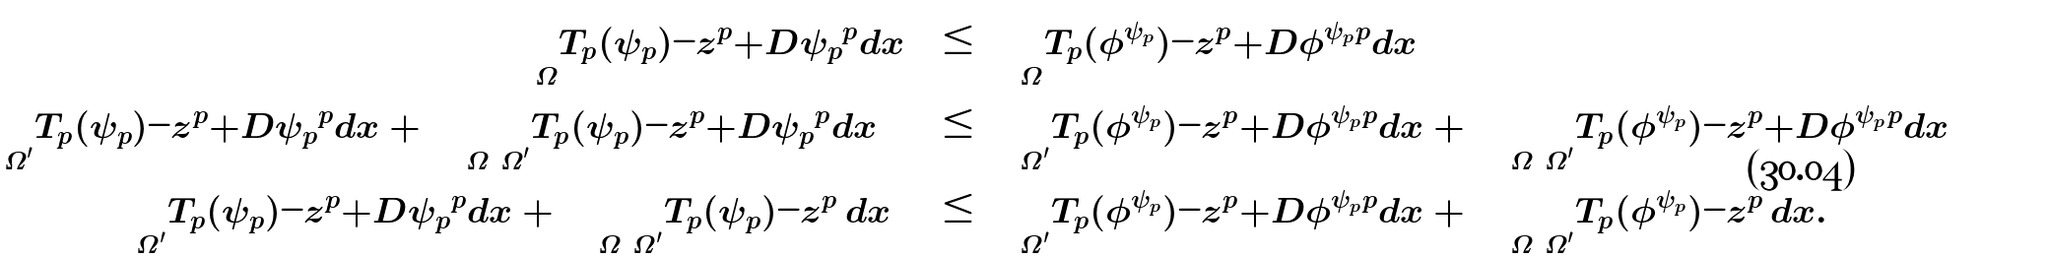Convert formula to latex. <formula><loc_0><loc_0><loc_500><loc_500>\int _ { \Omega } | T _ { p } ( \psi _ { p } ) - z | ^ { p } + | D \psi _ { p } | ^ { p } d x & \leq \int _ { \Omega } | T _ { p } ( \phi ^ { \psi _ { p } } ) - z | ^ { p } + | D \phi ^ { \psi _ { p } } | ^ { p } d x \\ \int _ { \Omega ^ { \prime } } | T _ { p } ( \psi _ { p } ) - z | ^ { p } + | D \psi _ { p } | ^ { p } d x + \int _ { \Omega \ \Omega ^ { \prime } } | T _ { p } ( \psi _ { p } ) - z | ^ { p } + | D \psi _ { p } | ^ { p } d x & \leq \int _ { \Omega ^ { \prime } } | T _ { p } ( \phi ^ { \psi _ { p } } ) - z | ^ { p } + | D \phi ^ { \psi _ { p } } | ^ { p } d x + \int _ { \Omega \ \Omega ^ { \prime } } | T _ { p } ( \phi ^ { \psi _ { p } } ) - z | ^ { p } + | D \phi ^ { \psi _ { p } } | ^ { p } d x \\ \int _ { \Omega ^ { \prime } } | T _ { p } ( \psi _ { p } ) - z | ^ { p } + | D \psi _ { p } | ^ { p } d x + \int _ { \Omega \ \Omega ^ { \prime } } | T _ { p } ( \psi _ { p } ) - z | ^ { p } \, d x & \leq \int _ { \Omega ^ { \prime } } | T _ { p } ( \phi ^ { \psi _ { p } } ) - z | ^ { p } + | D \phi ^ { \psi _ { p } } | ^ { p } d x + \int _ { \Omega \ \Omega ^ { \prime } } | T _ { p } ( \phi ^ { \psi _ { p } } ) - z | ^ { p } \, d x . \\</formula> 